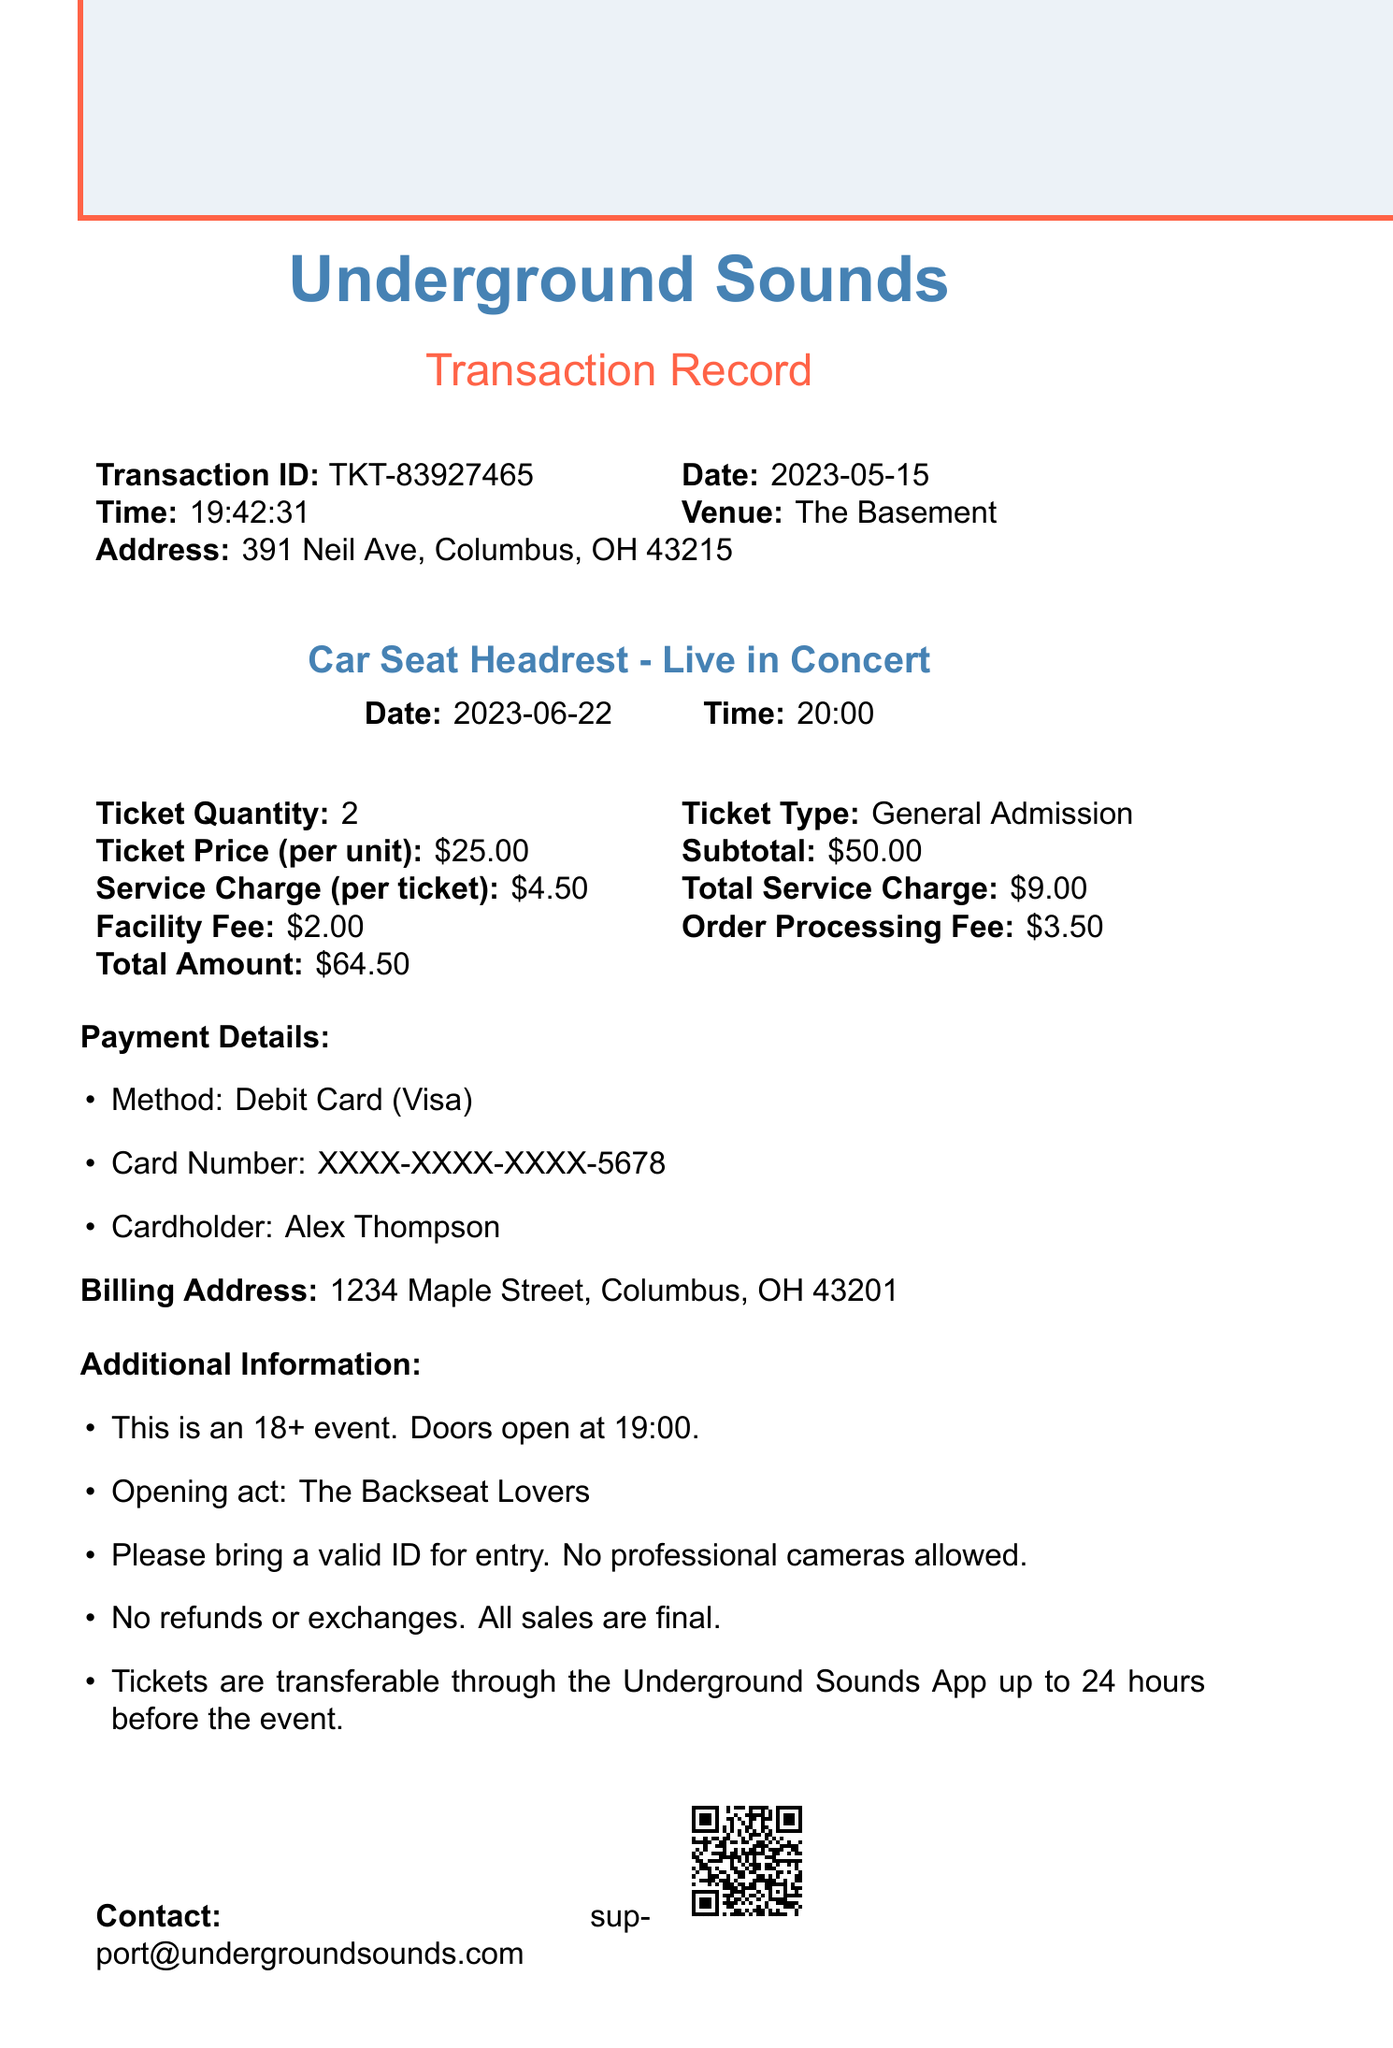what is the transaction ID? The transaction ID is a unique identifier for this purchase, which is TKT-83927465.
Answer: TKT-83927465 what is the venue name? The venue name where the concert will take place is mentioned in the document as The Basement.
Answer: The Basement how many tickets were purchased? The document indicates the quantity of tickets purchased, which is 2.
Answer: 2 what is the total amount paid? The total amount is the sum of all charges and fees, detailed in the document, which is $64.50.
Answer: $64.50 what is the date of the concert? The concert date is specified clearly in the document as June 22, 2023.
Answer: 2023-06-22 what service charge per ticket is applied? The service charge per ticket is listed in the document as $4.50.
Answer: $4.50 is it possible to transfer tickets? The document states the ticket transfer policy, which allows transfer through the app under certain conditions.
Answer: Yes what is the refund policy? The refund policy is clearly described in the document as no refunds or exchanges, all sales are final.
Answer: No refunds or exchanges who is the opening act? The document mentions the opening act for the concert, which is The Backseat Lovers.
Answer: The Backseat Lovers 